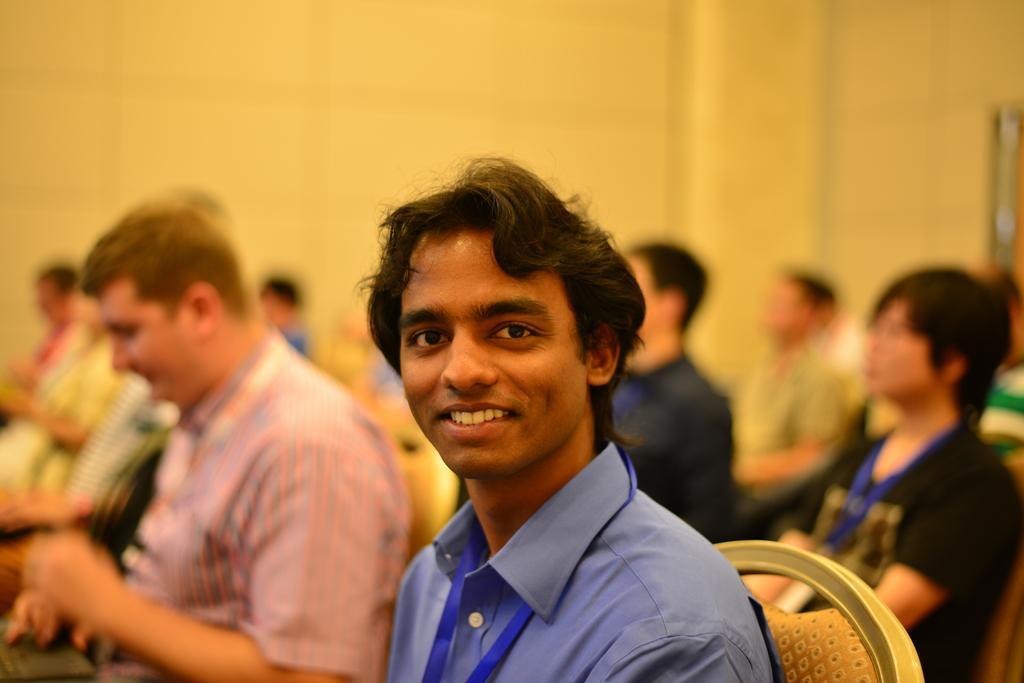How would you summarize this image in a sentence or two? In this picture there is a man in the center of the image, who is sitting on the chairs and there are other people in the background area of the image. 